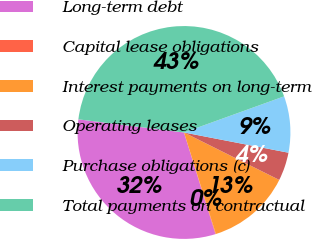Convert chart to OTSL. <chart><loc_0><loc_0><loc_500><loc_500><pie_chart><fcel>Long-term debt<fcel>Capital lease obligations<fcel>Interest payments on long-term<fcel>Operating leases<fcel>Purchase obligations (c)<fcel>Total payments on contractual<nl><fcel>31.75%<fcel>0.07%<fcel>12.8%<fcel>4.31%<fcel>8.56%<fcel>42.52%<nl></chart> 